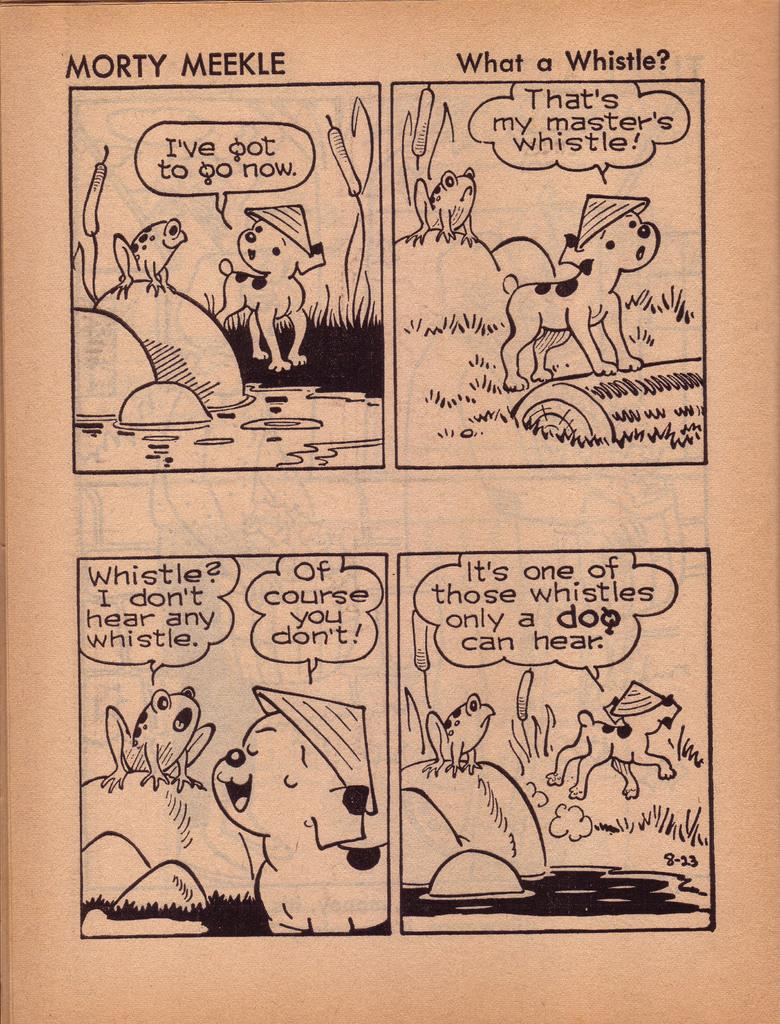<image>
Summarize the visual content of the image. a comic page that is titled 'morty meekle what a whistle?' 